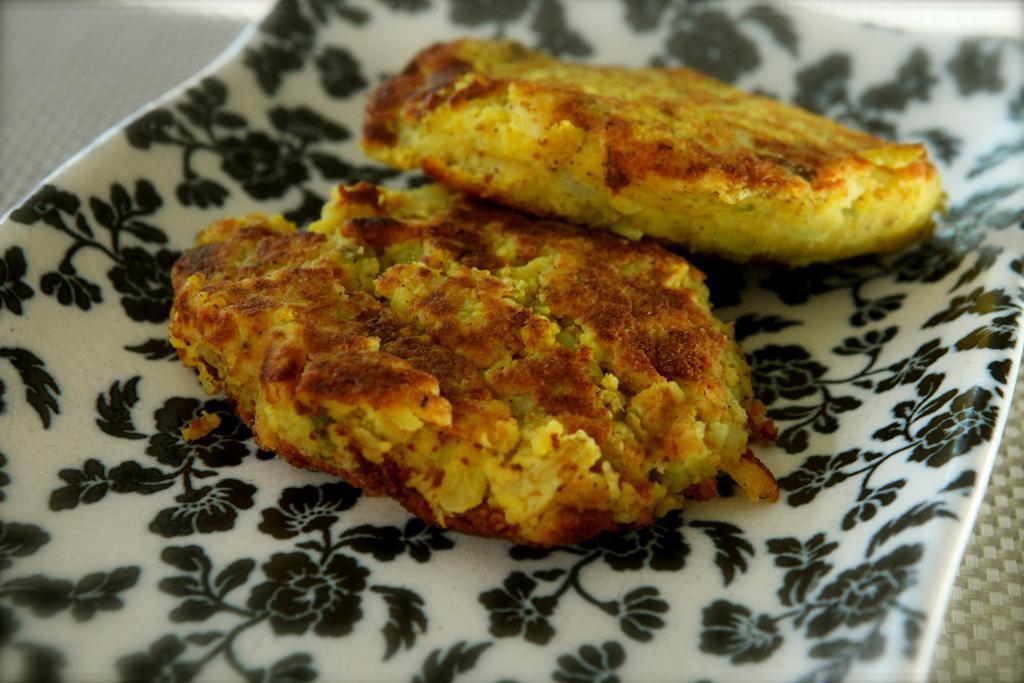Can you describe this image briefly? In the image in the center there is a cloth. On the cloth, we can see one plate. In the plate, we can see some food items. 